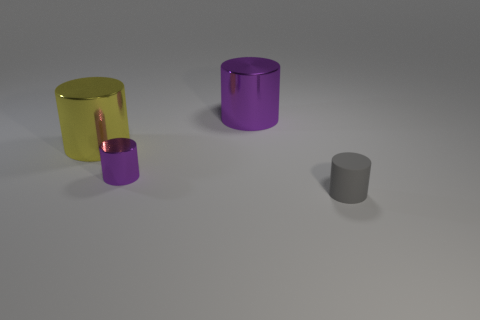Subtract all cyan spheres. How many purple cylinders are left? 2 Subtract all shiny cylinders. How many cylinders are left? 1 Add 2 matte objects. How many objects exist? 6 Subtract all purple cylinders. How many cylinders are left? 2 Subtract all red cylinders. Subtract all cyan cubes. How many cylinders are left? 4 Subtract all large purple cylinders. Subtract all matte things. How many objects are left? 2 Add 3 small gray cylinders. How many small gray cylinders are left? 4 Add 1 red matte objects. How many red matte objects exist? 1 Subtract 1 gray cylinders. How many objects are left? 3 